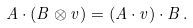<formula> <loc_0><loc_0><loc_500><loc_500>A \cdot ( B \otimes v ) = ( A \cdot v ) \cdot B \, .</formula> 